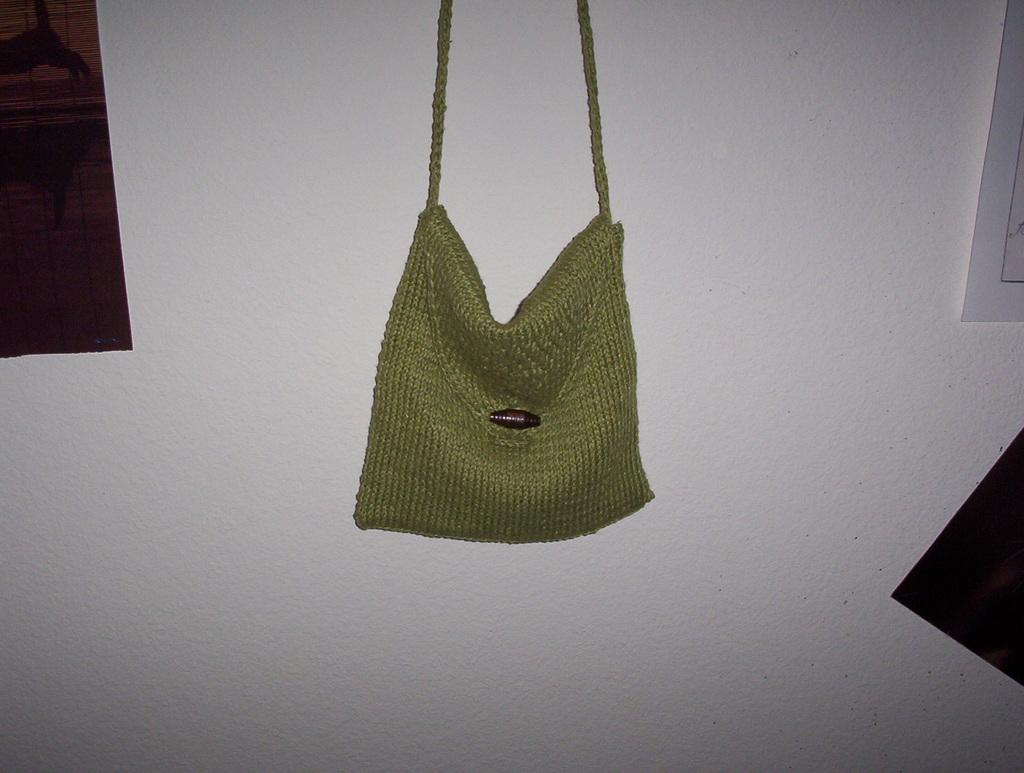What type of space is depicted in the image? There is a room in the image. What can be seen hanging on the wall in the room? A bag is hanging on the wall in the room. What color is the wall in the background of the image? There is a white color wall in the background. What architectural feature is visible in the background of the image? There is a window in the background. Can you see any jars filled with steam on the throne in the image? There is no throne or jar filled with steam present in the image. 